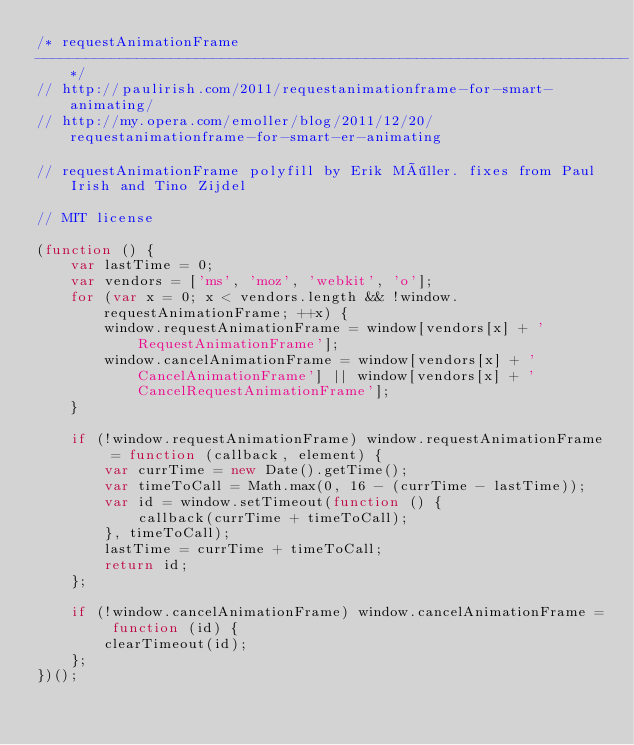<code> <loc_0><loc_0><loc_500><loc_500><_JavaScript_>/* requestAnimationFrame
----------------------------------------------------------------------*/
// http://paulirish.com/2011/requestanimationframe-for-smart-animating/
// http://my.opera.com/emoller/blog/2011/12/20/requestanimationframe-for-smart-er-animating

// requestAnimationFrame polyfill by Erik Möller. fixes from Paul Irish and Tino Zijdel

// MIT license

(function () {
	var lastTime = 0;
	var vendors = ['ms', 'moz', 'webkit', 'o'];
	for (var x = 0; x < vendors.length && !window.requestAnimationFrame; ++x) {
		window.requestAnimationFrame = window[vendors[x] + 'RequestAnimationFrame'];
		window.cancelAnimationFrame = window[vendors[x] + 'CancelAnimationFrame'] || window[vendors[x] + 'CancelRequestAnimationFrame'];
	}

	if (!window.requestAnimationFrame) window.requestAnimationFrame = function (callback, element) {
		var currTime = new Date().getTime();
		var timeToCall = Math.max(0, 16 - (currTime - lastTime));
		var id = window.setTimeout(function () {
			callback(currTime + timeToCall);
		}, timeToCall);
		lastTime = currTime + timeToCall;
		return id;
	};

	if (!window.cancelAnimationFrame) window.cancelAnimationFrame = function (id) {
		clearTimeout(id);
	};
})();
</code> 